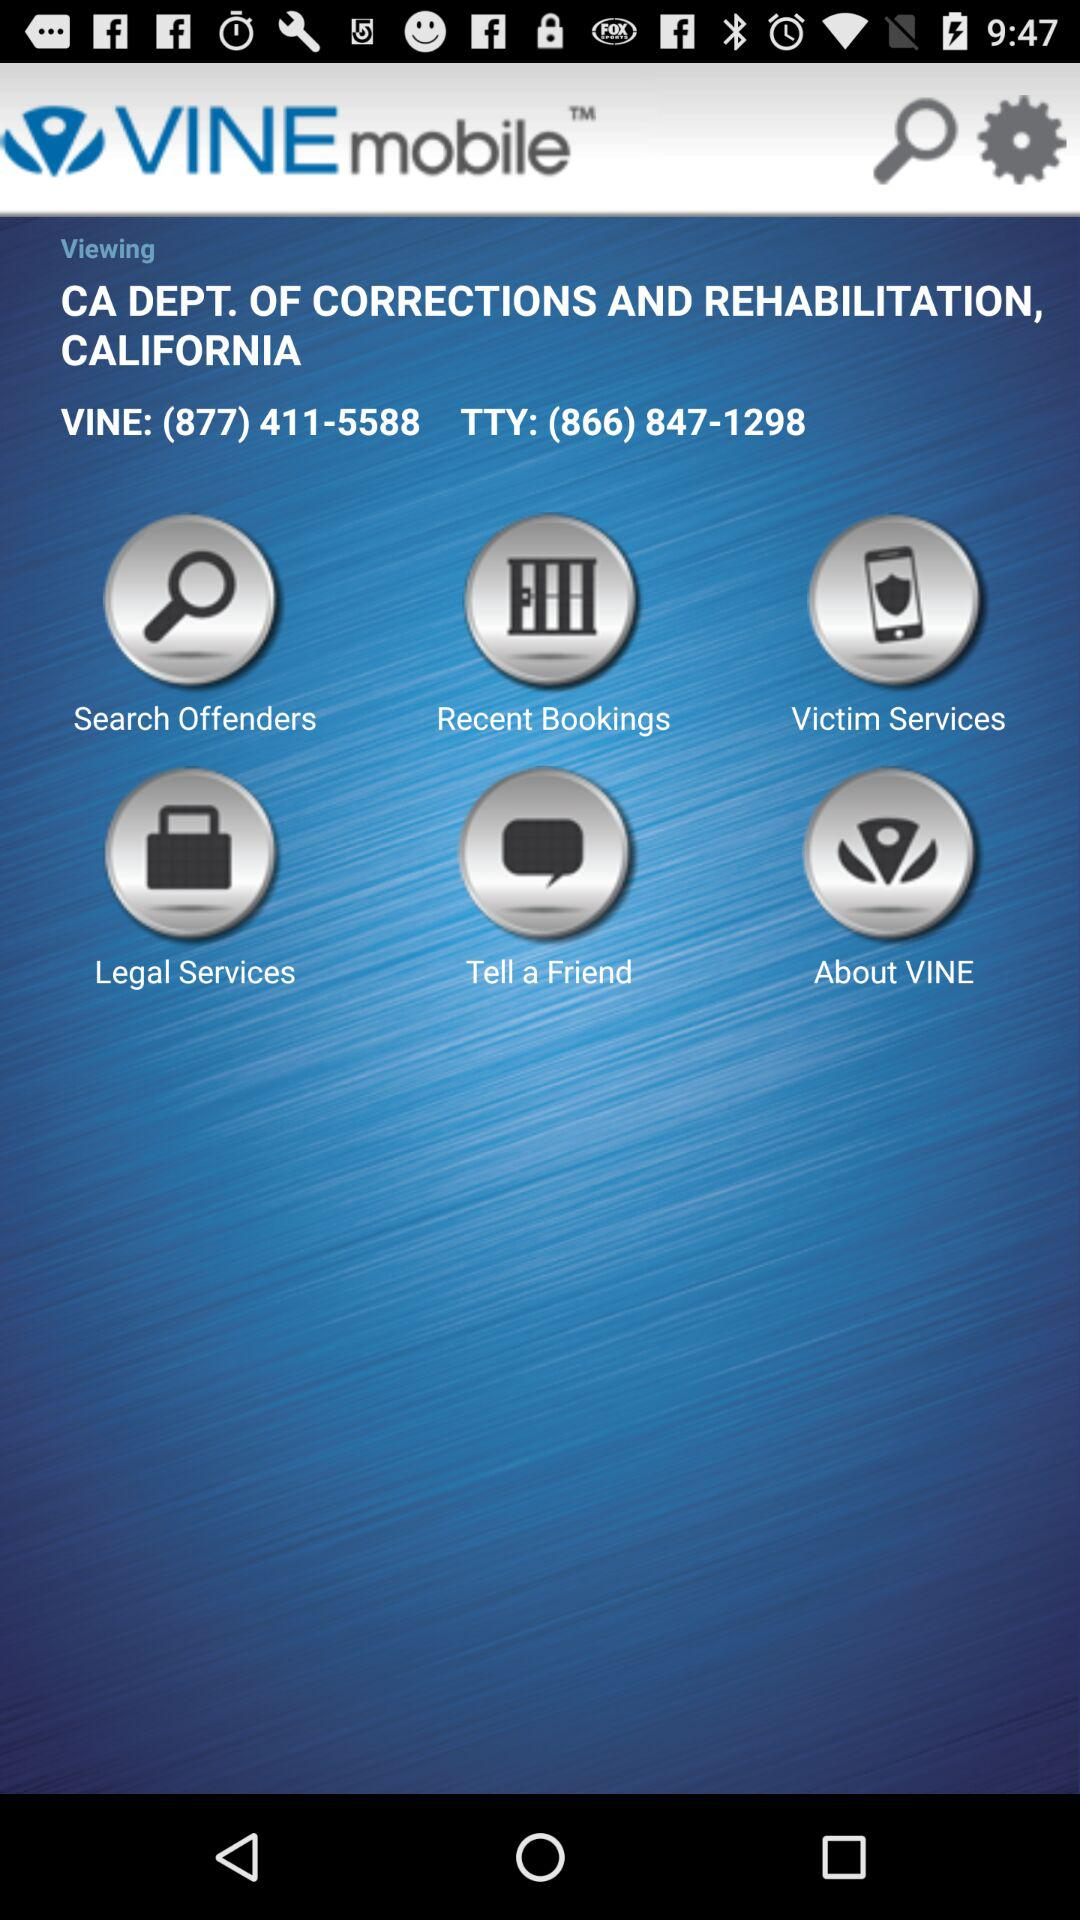What is the contact number of "VINE"? The contact number is (877) 411-5588. 